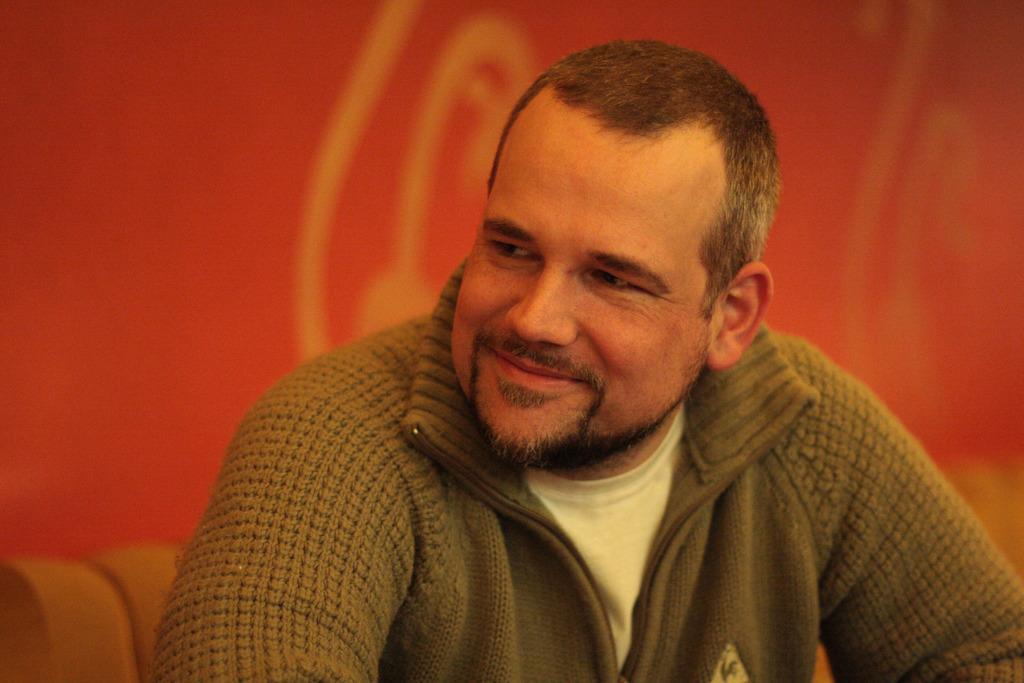Who is the main subject in the image? There is a man in the center of the image. What is the man doing in the image? The man is smiling in the image. What position does the man appear to be in? The man appears to be sitting in the image. What color is the object in the background of the image? There is a red color object in the background of the image. What type of badge is the man wearing in the image? There is no badge visible on the man in the image. What religious symbols can be seen in the image? There are no religious symbols present in the image. 